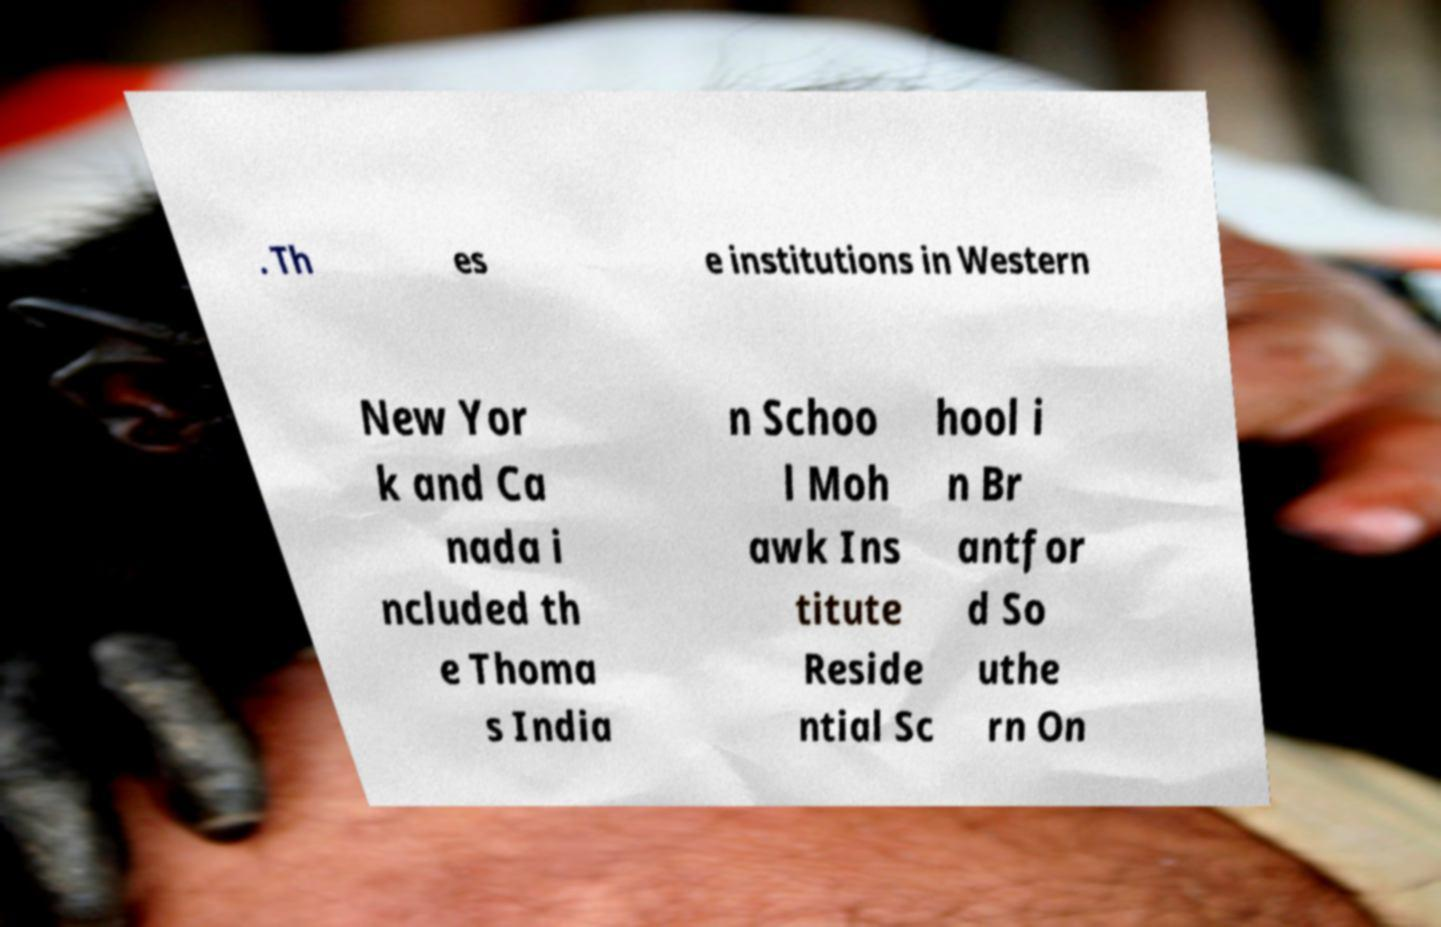Can you read and provide the text displayed in the image?This photo seems to have some interesting text. Can you extract and type it out for me? . Th es e institutions in Western New Yor k and Ca nada i ncluded th e Thoma s India n Schoo l Moh awk Ins titute Reside ntial Sc hool i n Br antfor d So uthe rn On 